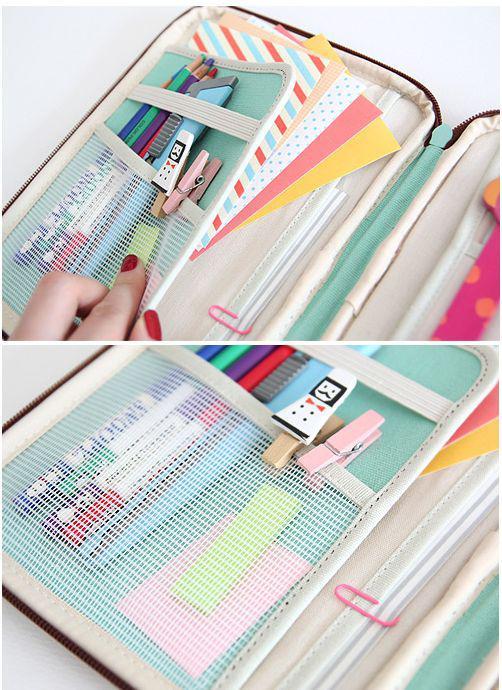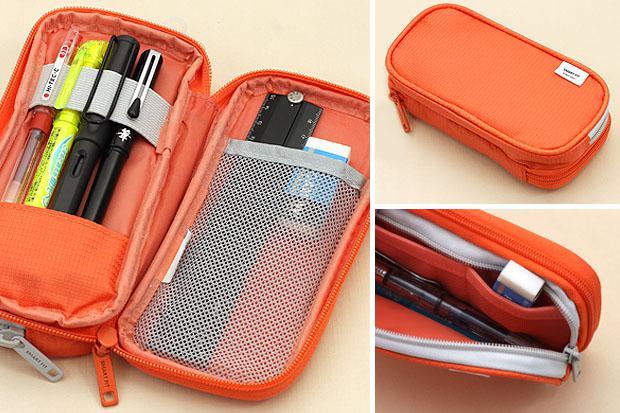The first image is the image on the left, the second image is the image on the right. Considering the images on both sides, is "An image collage shows a pencil case that opens clam-shell style, along with the same type case closed." valid? Answer yes or no. Yes. 